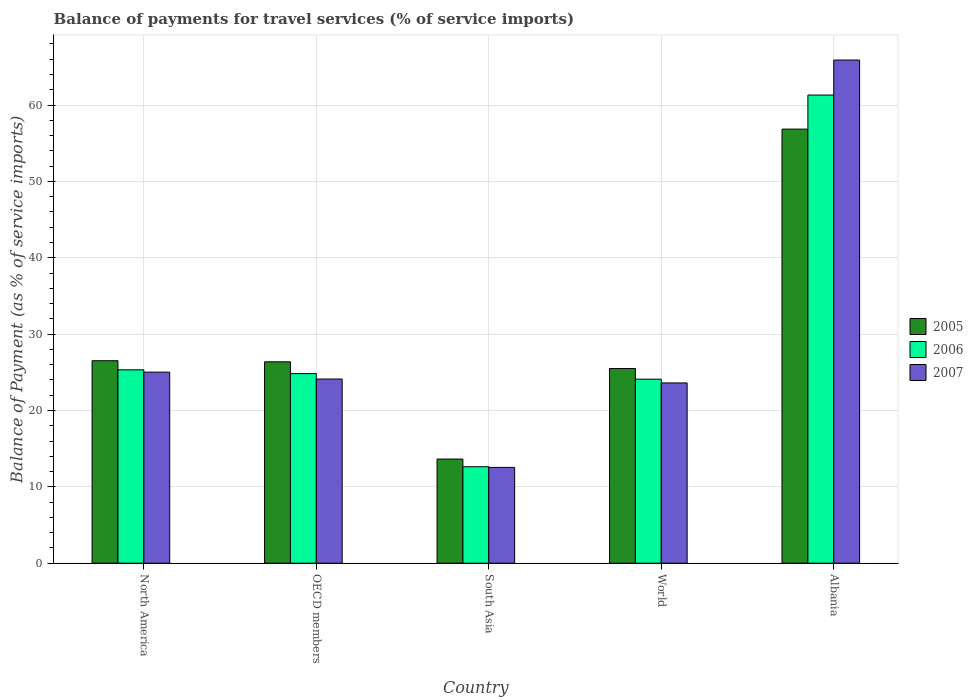Are the number of bars on each tick of the X-axis equal?
Give a very brief answer. Yes. How many bars are there on the 2nd tick from the right?
Your answer should be compact. 3. What is the label of the 3rd group of bars from the left?
Your answer should be compact. South Asia. In how many cases, is the number of bars for a given country not equal to the number of legend labels?
Your answer should be compact. 0. What is the balance of payments for travel services in 2006 in OECD members?
Offer a terse response. 24.83. Across all countries, what is the maximum balance of payments for travel services in 2005?
Your response must be concise. 56.85. Across all countries, what is the minimum balance of payments for travel services in 2005?
Keep it short and to the point. 13.64. In which country was the balance of payments for travel services in 2005 maximum?
Provide a succinct answer. Albania. In which country was the balance of payments for travel services in 2006 minimum?
Your answer should be compact. South Asia. What is the total balance of payments for travel services in 2005 in the graph?
Provide a short and direct response. 148.87. What is the difference between the balance of payments for travel services in 2006 in OECD members and that in World?
Keep it short and to the point. 0.73. What is the difference between the balance of payments for travel services in 2005 in North America and the balance of payments for travel services in 2007 in World?
Your response must be concise. 2.91. What is the average balance of payments for travel services in 2005 per country?
Your answer should be very brief. 29.77. What is the difference between the balance of payments for travel services of/in 2006 and balance of payments for travel services of/in 2007 in North America?
Provide a succinct answer. 0.3. What is the ratio of the balance of payments for travel services in 2005 in Albania to that in OECD members?
Give a very brief answer. 2.16. Is the balance of payments for travel services in 2007 in South Asia less than that in World?
Make the answer very short. Yes. What is the difference between the highest and the second highest balance of payments for travel services in 2005?
Provide a succinct answer. 30.33. What is the difference between the highest and the lowest balance of payments for travel services in 2005?
Your answer should be compact. 43.21. In how many countries, is the balance of payments for travel services in 2005 greater than the average balance of payments for travel services in 2005 taken over all countries?
Your answer should be very brief. 1. Is the sum of the balance of payments for travel services in 2007 in North America and World greater than the maximum balance of payments for travel services in 2006 across all countries?
Give a very brief answer. No. What does the 2nd bar from the left in South Asia represents?
Offer a very short reply. 2006. What does the 1st bar from the right in North America represents?
Offer a terse response. 2007. Are all the bars in the graph horizontal?
Your answer should be very brief. No. How many countries are there in the graph?
Offer a terse response. 5. What is the difference between two consecutive major ticks on the Y-axis?
Offer a very short reply. 10. Are the values on the major ticks of Y-axis written in scientific E-notation?
Your answer should be very brief. No. How many legend labels are there?
Your response must be concise. 3. What is the title of the graph?
Provide a succinct answer. Balance of payments for travel services (% of service imports). What is the label or title of the Y-axis?
Your answer should be compact. Balance of Payment (as % of service imports). What is the Balance of Payment (as % of service imports) in 2005 in North America?
Keep it short and to the point. 26.52. What is the Balance of Payment (as % of service imports) in 2006 in North America?
Your answer should be very brief. 25.32. What is the Balance of Payment (as % of service imports) of 2007 in North America?
Your answer should be compact. 25.02. What is the Balance of Payment (as % of service imports) of 2005 in OECD members?
Your answer should be compact. 26.37. What is the Balance of Payment (as % of service imports) in 2006 in OECD members?
Offer a terse response. 24.83. What is the Balance of Payment (as % of service imports) in 2007 in OECD members?
Offer a terse response. 24.12. What is the Balance of Payment (as % of service imports) in 2005 in South Asia?
Your answer should be compact. 13.64. What is the Balance of Payment (as % of service imports) of 2006 in South Asia?
Your response must be concise. 12.63. What is the Balance of Payment (as % of service imports) of 2007 in South Asia?
Your answer should be compact. 12.55. What is the Balance of Payment (as % of service imports) in 2005 in World?
Keep it short and to the point. 25.49. What is the Balance of Payment (as % of service imports) of 2006 in World?
Your answer should be compact. 24.1. What is the Balance of Payment (as % of service imports) in 2007 in World?
Your answer should be compact. 23.61. What is the Balance of Payment (as % of service imports) of 2005 in Albania?
Ensure brevity in your answer.  56.85. What is the Balance of Payment (as % of service imports) of 2006 in Albania?
Give a very brief answer. 61.31. What is the Balance of Payment (as % of service imports) of 2007 in Albania?
Keep it short and to the point. 65.89. Across all countries, what is the maximum Balance of Payment (as % of service imports) in 2005?
Offer a very short reply. 56.85. Across all countries, what is the maximum Balance of Payment (as % of service imports) of 2006?
Provide a short and direct response. 61.31. Across all countries, what is the maximum Balance of Payment (as % of service imports) in 2007?
Your response must be concise. 65.89. Across all countries, what is the minimum Balance of Payment (as % of service imports) in 2005?
Your response must be concise. 13.64. Across all countries, what is the minimum Balance of Payment (as % of service imports) of 2006?
Your response must be concise. 12.63. Across all countries, what is the minimum Balance of Payment (as % of service imports) in 2007?
Offer a terse response. 12.55. What is the total Balance of Payment (as % of service imports) of 2005 in the graph?
Offer a very short reply. 148.87. What is the total Balance of Payment (as % of service imports) of 2006 in the graph?
Your answer should be very brief. 148.2. What is the total Balance of Payment (as % of service imports) in 2007 in the graph?
Your response must be concise. 151.19. What is the difference between the Balance of Payment (as % of service imports) of 2005 in North America and that in OECD members?
Provide a short and direct response. 0.14. What is the difference between the Balance of Payment (as % of service imports) in 2006 in North America and that in OECD members?
Give a very brief answer. 0.49. What is the difference between the Balance of Payment (as % of service imports) in 2007 in North America and that in OECD members?
Offer a terse response. 0.9. What is the difference between the Balance of Payment (as % of service imports) of 2005 in North America and that in South Asia?
Your answer should be very brief. 12.88. What is the difference between the Balance of Payment (as % of service imports) in 2006 in North America and that in South Asia?
Offer a terse response. 12.69. What is the difference between the Balance of Payment (as % of service imports) of 2007 in North America and that in South Asia?
Ensure brevity in your answer.  12.47. What is the difference between the Balance of Payment (as % of service imports) of 2005 in North America and that in World?
Provide a succinct answer. 1.02. What is the difference between the Balance of Payment (as % of service imports) of 2006 in North America and that in World?
Give a very brief answer. 1.22. What is the difference between the Balance of Payment (as % of service imports) of 2007 in North America and that in World?
Your response must be concise. 1.41. What is the difference between the Balance of Payment (as % of service imports) in 2005 in North America and that in Albania?
Ensure brevity in your answer.  -30.33. What is the difference between the Balance of Payment (as % of service imports) in 2006 in North America and that in Albania?
Your answer should be very brief. -35.98. What is the difference between the Balance of Payment (as % of service imports) in 2007 in North America and that in Albania?
Offer a very short reply. -40.87. What is the difference between the Balance of Payment (as % of service imports) of 2005 in OECD members and that in South Asia?
Your response must be concise. 12.73. What is the difference between the Balance of Payment (as % of service imports) in 2006 in OECD members and that in South Asia?
Provide a short and direct response. 12.2. What is the difference between the Balance of Payment (as % of service imports) of 2007 in OECD members and that in South Asia?
Provide a succinct answer. 11.57. What is the difference between the Balance of Payment (as % of service imports) of 2005 in OECD members and that in World?
Keep it short and to the point. 0.88. What is the difference between the Balance of Payment (as % of service imports) of 2006 in OECD members and that in World?
Keep it short and to the point. 0.73. What is the difference between the Balance of Payment (as % of service imports) of 2007 in OECD members and that in World?
Provide a short and direct response. 0.51. What is the difference between the Balance of Payment (as % of service imports) of 2005 in OECD members and that in Albania?
Provide a succinct answer. -30.47. What is the difference between the Balance of Payment (as % of service imports) in 2006 in OECD members and that in Albania?
Provide a short and direct response. -36.48. What is the difference between the Balance of Payment (as % of service imports) of 2007 in OECD members and that in Albania?
Your response must be concise. -41.77. What is the difference between the Balance of Payment (as % of service imports) of 2005 in South Asia and that in World?
Provide a succinct answer. -11.85. What is the difference between the Balance of Payment (as % of service imports) of 2006 in South Asia and that in World?
Make the answer very short. -11.47. What is the difference between the Balance of Payment (as % of service imports) in 2007 in South Asia and that in World?
Give a very brief answer. -11.06. What is the difference between the Balance of Payment (as % of service imports) of 2005 in South Asia and that in Albania?
Provide a succinct answer. -43.21. What is the difference between the Balance of Payment (as % of service imports) of 2006 in South Asia and that in Albania?
Offer a very short reply. -48.68. What is the difference between the Balance of Payment (as % of service imports) in 2007 in South Asia and that in Albania?
Your answer should be compact. -53.35. What is the difference between the Balance of Payment (as % of service imports) of 2005 in World and that in Albania?
Provide a succinct answer. -31.35. What is the difference between the Balance of Payment (as % of service imports) of 2006 in World and that in Albania?
Offer a very short reply. -37.21. What is the difference between the Balance of Payment (as % of service imports) in 2007 in World and that in Albania?
Your answer should be compact. -42.28. What is the difference between the Balance of Payment (as % of service imports) of 2005 in North America and the Balance of Payment (as % of service imports) of 2006 in OECD members?
Offer a very short reply. 1.68. What is the difference between the Balance of Payment (as % of service imports) of 2005 in North America and the Balance of Payment (as % of service imports) of 2007 in OECD members?
Ensure brevity in your answer.  2.4. What is the difference between the Balance of Payment (as % of service imports) in 2006 in North America and the Balance of Payment (as % of service imports) in 2007 in OECD members?
Offer a terse response. 1.2. What is the difference between the Balance of Payment (as % of service imports) in 2005 in North America and the Balance of Payment (as % of service imports) in 2006 in South Asia?
Make the answer very short. 13.88. What is the difference between the Balance of Payment (as % of service imports) of 2005 in North America and the Balance of Payment (as % of service imports) of 2007 in South Asia?
Provide a short and direct response. 13.97. What is the difference between the Balance of Payment (as % of service imports) of 2006 in North America and the Balance of Payment (as % of service imports) of 2007 in South Asia?
Your answer should be very brief. 12.78. What is the difference between the Balance of Payment (as % of service imports) of 2005 in North America and the Balance of Payment (as % of service imports) of 2006 in World?
Your response must be concise. 2.41. What is the difference between the Balance of Payment (as % of service imports) of 2005 in North America and the Balance of Payment (as % of service imports) of 2007 in World?
Offer a very short reply. 2.91. What is the difference between the Balance of Payment (as % of service imports) in 2006 in North America and the Balance of Payment (as % of service imports) in 2007 in World?
Your answer should be compact. 1.72. What is the difference between the Balance of Payment (as % of service imports) in 2005 in North America and the Balance of Payment (as % of service imports) in 2006 in Albania?
Your response must be concise. -34.79. What is the difference between the Balance of Payment (as % of service imports) of 2005 in North America and the Balance of Payment (as % of service imports) of 2007 in Albania?
Keep it short and to the point. -39.38. What is the difference between the Balance of Payment (as % of service imports) of 2006 in North America and the Balance of Payment (as % of service imports) of 2007 in Albania?
Offer a very short reply. -40.57. What is the difference between the Balance of Payment (as % of service imports) of 2005 in OECD members and the Balance of Payment (as % of service imports) of 2006 in South Asia?
Keep it short and to the point. 13.74. What is the difference between the Balance of Payment (as % of service imports) in 2005 in OECD members and the Balance of Payment (as % of service imports) in 2007 in South Asia?
Make the answer very short. 13.83. What is the difference between the Balance of Payment (as % of service imports) in 2006 in OECD members and the Balance of Payment (as % of service imports) in 2007 in South Asia?
Ensure brevity in your answer.  12.28. What is the difference between the Balance of Payment (as % of service imports) of 2005 in OECD members and the Balance of Payment (as % of service imports) of 2006 in World?
Make the answer very short. 2.27. What is the difference between the Balance of Payment (as % of service imports) of 2005 in OECD members and the Balance of Payment (as % of service imports) of 2007 in World?
Offer a very short reply. 2.76. What is the difference between the Balance of Payment (as % of service imports) in 2006 in OECD members and the Balance of Payment (as % of service imports) in 2007 in World?
Your answer should be very brief. 1.22. What is the difference between the Balance of Payment (as % of service imports) of 2005 in OECD members and the Balance of Payment (as % of service imports) of 2006 in Albania?
Offer a terse response. -34.94. What is the difference between the Balance of Payment (as % of service imports) in 2005 in OECD members and the Balance of Payment (as % of service imports) in 2007 in Albania?
Keep it short and to the point. -39.52. What is the difference between the Balance of Payment (as % of service imports) of 2006 in OECD members and the Balance of Payment (as % of service imports) of 2007 in Albania?
Your response must be concise. -41.06. What is the difference between the Balance of Payment (as % of service imports) in 2005 in South Asia and the Balance of Payment (as % of service imports) in 2006 in World?
Your response must be concise. -10.46. What is the difference between the Balance of Payment (as % of service imports) in 2005 in South Asia and the Balance of Payment (as % of service imports) in 2007 in World?
Your answer should be compact. -9.97. What is the difference between the Balance of Payment (as % of service imports) in 2006 in South Asia and the Balance of Payment (as % of service imports) in 2007 in World?
Ensure brevity in your answer.  -10.97. What is the difference between the Balance of Payment (as % of service imports) of 2005 in South Asia and the Balance of Payment (as % of service imports) of 2006 in Albania?
Ensure brevity in your answer.  -47.67. What is the difference between the Balance of Payment (as % of service imports) of 2005 in South Asia and the Balance of Payment (as % of service imports) of 2007 in Albania?
Give a very brief answer. -52.25. What is the difference between the Balance of Payment (as % of service imports) in 2006 in South Asia and the Balance of Payment (as % of service imports) in 2007 in Albania?
Make the answer very short. -53.26. What is the difference between the Balance of Payment (as % of service imports) of 2005 in World and the Balance of Payment (as % of service imports) of 2006 in Albania?
Provide a short and direct response. -35.81. What is the difference between the Balance of Payment (as % of service imports) of 2005 in World and the Balance of Payment (as % of service imports) of 2007 in Albania?
Your answer should be very brief. -40.4. What is the difference between the Balance of Payment (as % of service imports) in 2006 in World and the Balance of Payment (as % of service imports) in 2007 in Albania?
Ensure brevity in your answer.  -41.79. What is the average Balance of Payment (as % of service imports) in 2005 per country?
Your response must be concise. 29.77. What is the average Balance of Payment (as % of service imports) in 2006 per country?
Give a very brief answer. 29.64. What is the average Balance of Payment (as % of service imports) of 2007 per country?
Make the answer very short. 30.24. What is the difference between the Balance of Payment (as % of service imports) in 2005 and Balance of Payment (as % of service imports) in 2006 in North America?
Provide a succinct answer. 1.19. What is the difference between the Balance of Payment (as % of service imports) in 2005 and Balance of Payment (as % of service imports) in 2007 in North America?
Give a very brief answer. 1.49. What is the difference between the Balance of Payment (as % of service imports) of 2006 and Balance of Payment (as % of service imports) of 2007 in North America?
Your response must be concise. 0.3. What is the difference between the Balance of Payment (as % of service imports) of 2005 and Balance of Payment (as % of service imports) of 2006 in OECD members?
Your answer should be compact. 1.54. What is the difference between the Balance of Payment (as % of service imports) in 2005 and Balance of Payment (as % of service imports) in 2007 in OECD members?
Offer a terse response. 2.25. What is the difference between the Balance of Payment (as % of service imports) in 2006 and Balance of Payment (as % of service imports) in 2007 in OECD members?
Your answer should be compact. 0.71. What is the difference between the Balance of Payment (as % of service imports) in 2005 and Balance of Payment (as % of service imports) in 2006 in South Asia?
Provide a short and direct response. 1.01. What is the difference between the Balance of Payment (as % of service imports) of 2005 and Balance of Payment (as % of service imports) of 2007 in South Asia?
Offer a terse response. 1.09. What is the difference between the Balance of Payment (as % of service imports) in 2006 and Balance of Payment (as % of service imports) in 2007 in South Asia?
Give a very brief answer. 0.09. What is the difference between the Balance of Payment (as % of service imports) in 2005 and Balance of Payment (as % of service imports) in 2006 in World?
Your response must be concise. 1.39. What is the difference between the Balance of Payment (as % of service imports) of 2005 and Balance of Payment (as % of service imports) of 2007 in World?
Keep it short and to the point. 1.89. What is the difference between the Balance of Payment (as % of service imports) of 2006 and Balance of Payment (as % of service imports) of 2007 in World?
Ensure brevity in your answer.  0.49. What is the difference between the Balance of Payment (as % of service imports) of 2005 and Balance of Payment (as % of service imports) of 2006 in Albania?
Provide a succinct answer. -4.46. What is the difference between the Balance of Payment (as % of service imports) of 2005 and Balance of Payment (as % of service imports) of 2007 in Albania?
Your answer should be compact. -9.05. What is the difference between the Balance of Payment (as % of service imports) of 2006 and Balance of Payment (as % of service imports) of 2007 in Albania?
Keep it short and to the point. -4.58. What is the ratio of the Balance of Payment (as % of service imports) in 2005 in North America to that in OECD members?
Ensure brevity in your answer.  1.01. What is the ratio of the Balance of Payment (as % of service imports) in 2006 in North America to that in OECD members?
Make the answer very short. 1.02. What is the ratio of the Balance of Payment (as % of service imports) in 2007 in North America to that in OECD members?
Your response must be concise. 1.04. What is the ratio of the Balance of Payment (as % of service imports) in 2005 in North America to that in South Asia?
Provide a succinct answer. 1.94. What is the ratio of the Balance of Payment (as % of service imports) in 2006 in North America to that in South Asia?
Offer a very short reply. 2. What is the ratio of the Balance of Payment (as % of service imports) of 2007 in North America to that in South Asia?
Make the answer very short. 1.99. What is the ratio of the Balance of Payment (as % of service imports) in 2005 in North America to that in World?
Make the answer very short. 1.04. What is the ratio of the Balance of Payment (as % of service imports) of 2006 in North America to that in World?
Offer a terse response. 1.05. What is the ratio of the Balance of Payment (as % of service imports) in 2007 in North America to that in World?
Ensure brevity in your answer.  1.06. What is the ratio of the Balance of Payment (as % of service imports) in 2005 in North America to that in Albania?
Give a very brief answer. 0.47. What is the ratio of the Balance of Payment (as % of service imports) of 2006 in North America to that in Albania?
Make the answer very short. 0.41. What is the ratio of the Balance of Payment (as % of service imports) in 2007 in North America to that in Albania?
Give a very brief answer. 0.38. What is the ratio of the Balance of Payment (as % of service imports) in 2005 in OECD members to that in South Asia?
Provide a succinct answer. 1.93. What is the ratio of the Balance of Payment (as % of service imports) in 2006 in OECD members to that in South Asia?
Your response must be concise. 1.97. What is the ratio of the Balance of Payment (as % of service imports) of 2007 in OECD members to that in South Asia?
Your answer should be very brief. 1.92. What is the ratio of the Balance of Payment (as % of service imports) in 2005 in OECD members to that in World?
Offer a very short reply. 1.03. What is the ratio of the Balance of Payment (as % of service imports) of 2006 in OECD members to that in World?
Offer a very short reply. 1.03. What is the ratio of the Balance of Payment (as % of service imports) in 2007 in OECD members to that in World?
Provide a short and direct response. 1.02. What is the ratio of the Balance of Payment (as % of service imports) in 2005 in OECD members to that in Albania?
Ensure brevity in your answer.  0.46. What is the ratio of the Balance of Payment (as % of service imports) in 2006 in OECD members to that in Albania?
Offer a very short reply. 0.41. What is the ratio of the Balance of Payment (as % of service imports) in 2007 in OECD members to that in Albania?
Your answer should be very brief. 0.37. What is the ratio of the Balance of Payment (as % of service imports) of 2005 in South Asia to that in World?
Give a very brief answer. 0.54. What is the ratio of the Balance of Payment (as % of service imports) in 2006 in South Asia to that in World?
Offer a very short reply. 0.52. What is the ratio of the Balance of Payment (as % of service imports) in 2007 in South Asia to that in World?
Your response must be concise. 0.53. What is the ratio of the Balance of Payment (as % of service imports) in 2005 in South Asia to that in Albania?
Offer a terse response. 0.24. What is the ratio of the Balance of Payment (as % of service imports) in 2006 in South Asia to that in Albania?
Provide a succinct answer. 0.21. What is the ratio of the Balance of Payment (as % of service imports) of 2007 in South Asia to that in Albania?
Provide a short and direct response. 0.19. What is the ratio of the Balance of Payment (as % of service imports) of 2005 in World to that in Albania?
Make the answer very short. 0.45. What is the ratio of the Balance of Payment (as % of service imports) of 2006 in World to that in Albania?
Your answer should be compact. 0.39. What is the ratio of the Balance of Payment (as % of service imports) in 2007 in World to that in Albania?
Provide a short and direct response. 0.36. What is the difference between the highest and the second highest Balance of Payment (as % of service imports) in 2005?
Your answer should be compact. 30.33. What is the difference between the highest and the second highest Balance of Payment (as % of service imports) in 2006?
Give a very brief answer. 35.98. What is the difference between the highest and the second highest Balance of Payment (as % of service imports) of 2007?
Provide a short and direct response. 40.87. What is the difference between the highest and the lowest Balance of Payment (as % of service imports) of 2005?
Your response must be concise. 43.21. What is the difference between the highest and the lowest Balance of Payment (as % of service imports) in 2006?
Provide a short and direct response. 48.68. What is the difference between the highest and the lowest Balance of Payment (as % of service imports) in 2007?
Give a very brief answer. 53.35. 